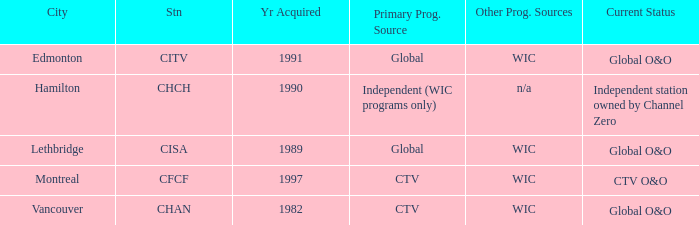How many is the minimum for citv 1991.0. 